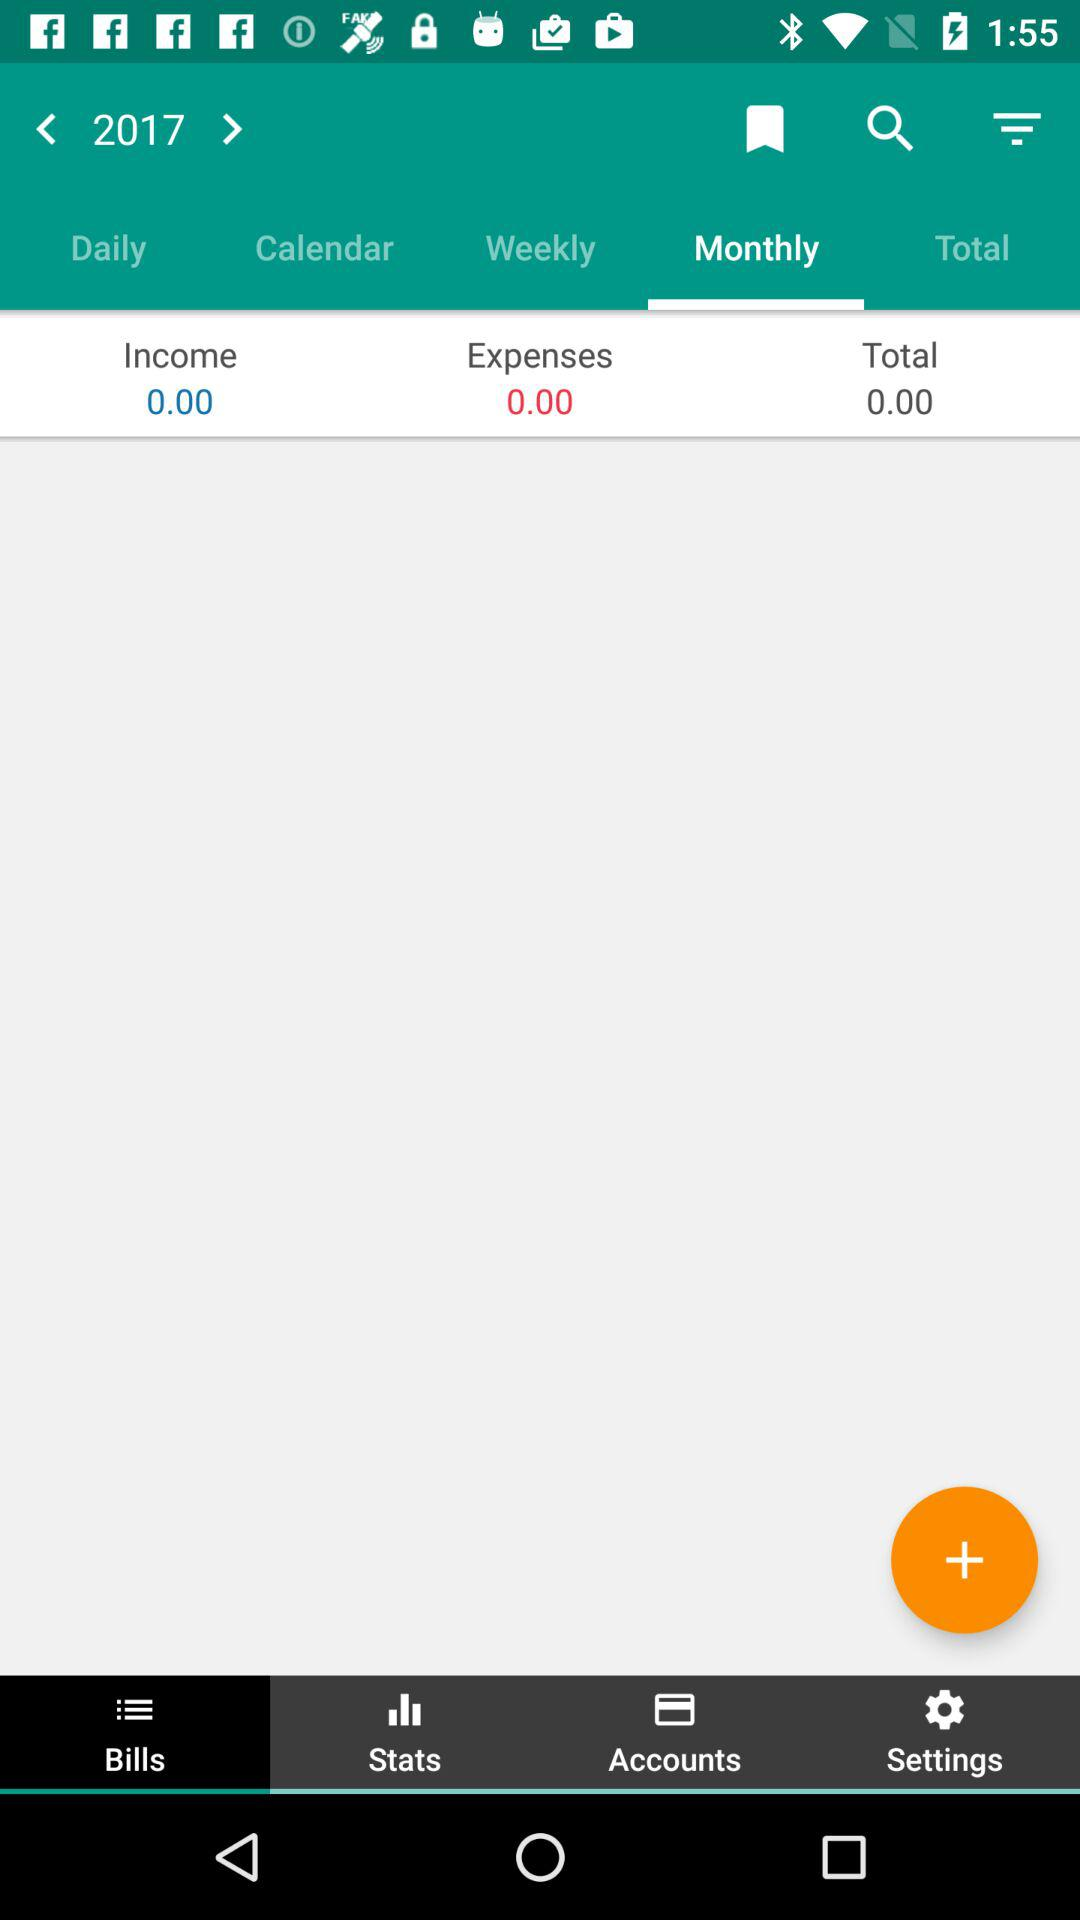What year of data is given? The given year of data is 2017. 